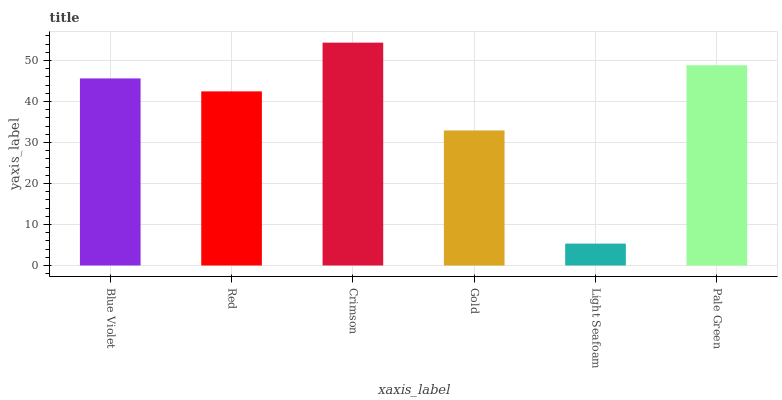Is Light Seafoam the minimum?
Answer yes or no. Yes. Is Crimson the maximum?
Answer yes or no. Yes. Is Red the minimum?
Answer yes or no. No. Is Red the maximum?
Answer yes or no. No. Is Blue Violet greater than Red?
Answer yes or no. Yes. Is Red less than Blue Violet?
Answer yes or no. Yes. Is Red greater than Blue Violet?
Answer yes or no. No. Is Blue Violet less than Red?
Answer yes or no. No. Is Blue Violet the high median?
Answer yes or no. Yes. Is Red the low median?
Answer yes or no. Yes. Is Crimson the high median?
Answer yes or no. No. Is Blue Violet the low median?
Answer yes or no. No. 